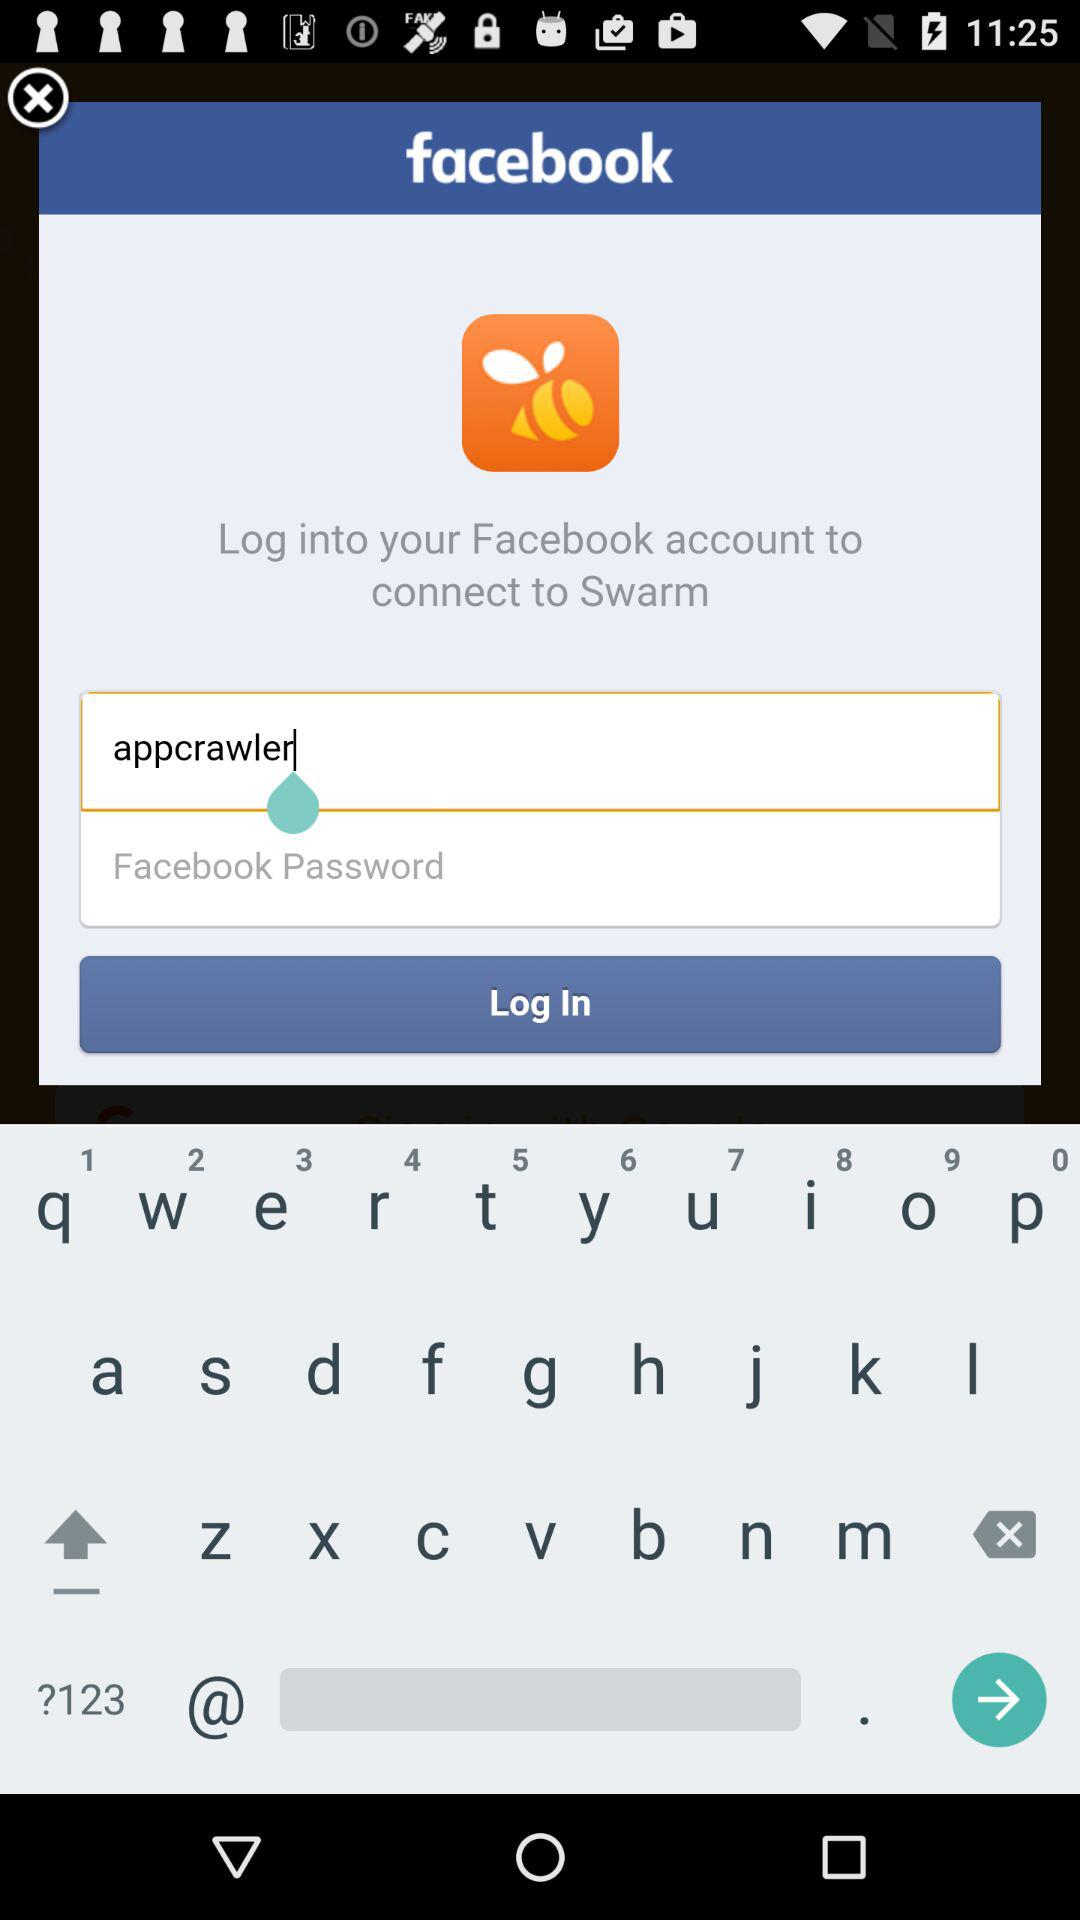How many text input fields are there on this screen?
Answer the question using a single word or phrase. 2 